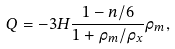<formula> <loc_0><loc_0><loc_500><loc_500>Q = - 3 H \frac { 1 - n / 6 } { 1 + \rho _ { m } / \rho _ { x } } \rho _ { m } ,</formula> 